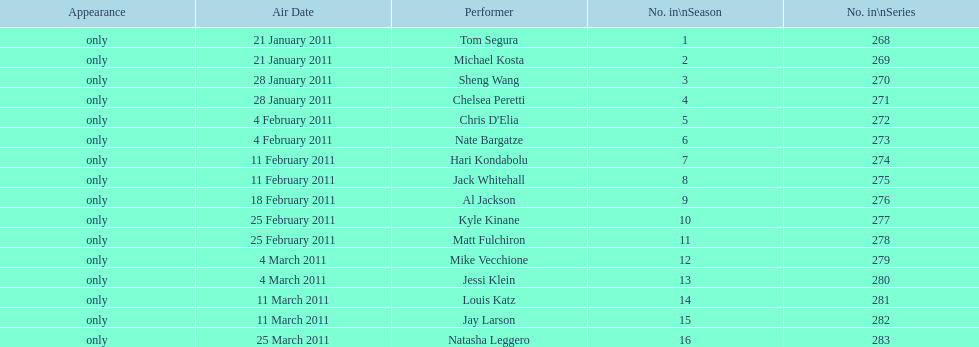What were the total number of air dates in february? 7. Would you be able to parse every entry in this table? {'header': ['Appearance', 'Air Date', 'Performer', 'No. in\\nSeason', 'No. in\\nSeries'], 'rows': [['only', '21 January 2011', 'Tom Segura', '1', '268'], ['only', '21 January 2011', 'Michael Kosta', '2', '269'], ['only', '28 January 2011', 'Sheng Wang', '3', '270'], ['only', '28 January 2011', 'Chelsea Peretti', '4', '271'], ['only', '4 February 2011', "Chris D'Elia", '5', '272'], ['only', '4 February 2011', 'Nate Bargatze', '6', '273'], ['only', '11 February 2011', 'Hari Kondabolu', '7', '274'], ['only', '11 February 2011', 'Jack Whitehall', '8', '275'], ['only', '18 February 2011', 'Al Jackson', '9', '276'], ['only', '25 February 2011', 'Kyle Kinane', '10', '277'], ['only', '25 February 2011', 'Matt Fulchiron', '11', '278'], ['only', '4 March 2011', 'Mike Vecchione', '12', '279'], ['only', '4 March 2011', 'Jessi Klein', '13', '280'], ['only', '11 March 2011', 'Louis Katz', '14', '281'], ['only', '11 March 2011', 'Jay Larson', '15', '282'], ['only', '25 March 2011', 'Natasha Leggero', '16', '283']]} 